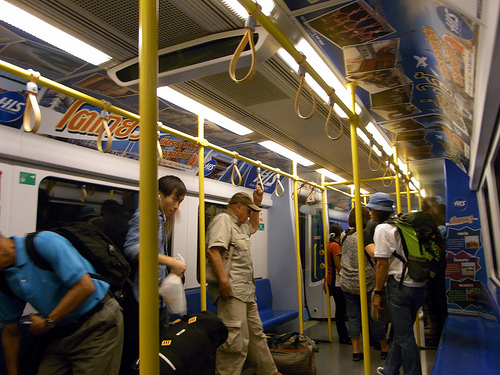<image>
Is there a bag to the left of the man? Yes. From this viewpoint, the bag is positioned to the left side relative to the man. 